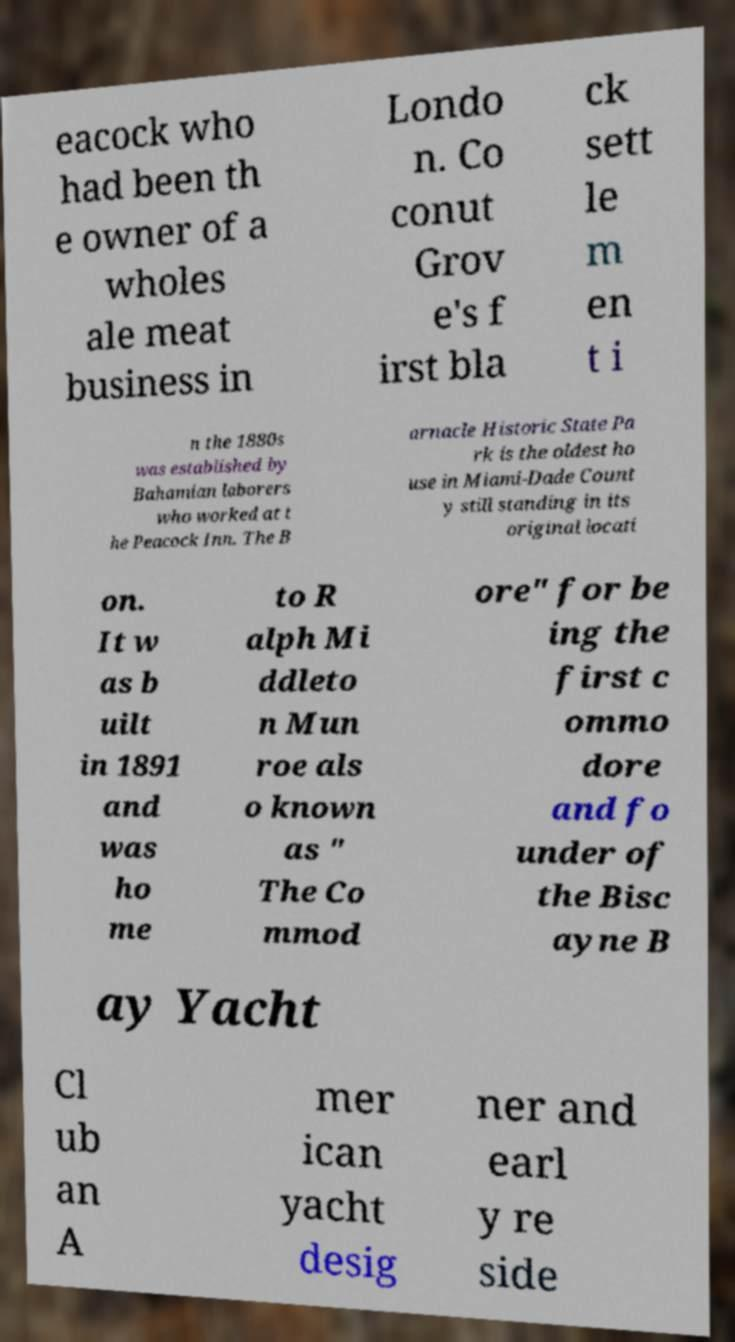I need the written content from this picture converted into text. Can you do that? eacock who had been th e owner of a wholes ale meat business in Londo n. Co conut Grov e's f irst bla ck sett le m en t i n the 1880s was established by Bahamian laborers who worked at t he Peacock Inn. The B arnacle Historic State Pa rk is the oldest ho use in Miami-Dade Count y still standing in its original locati on. It w as b uilt in 1891 and was ho me to R alph Mi ddleto n Mun roe als o known as " The Co mmod ore" for be ing the first c ommo dore and fo under of the Bisc ayne B ay Yacht Cl ub an A mer ican yacht desig ner and earl y re side 